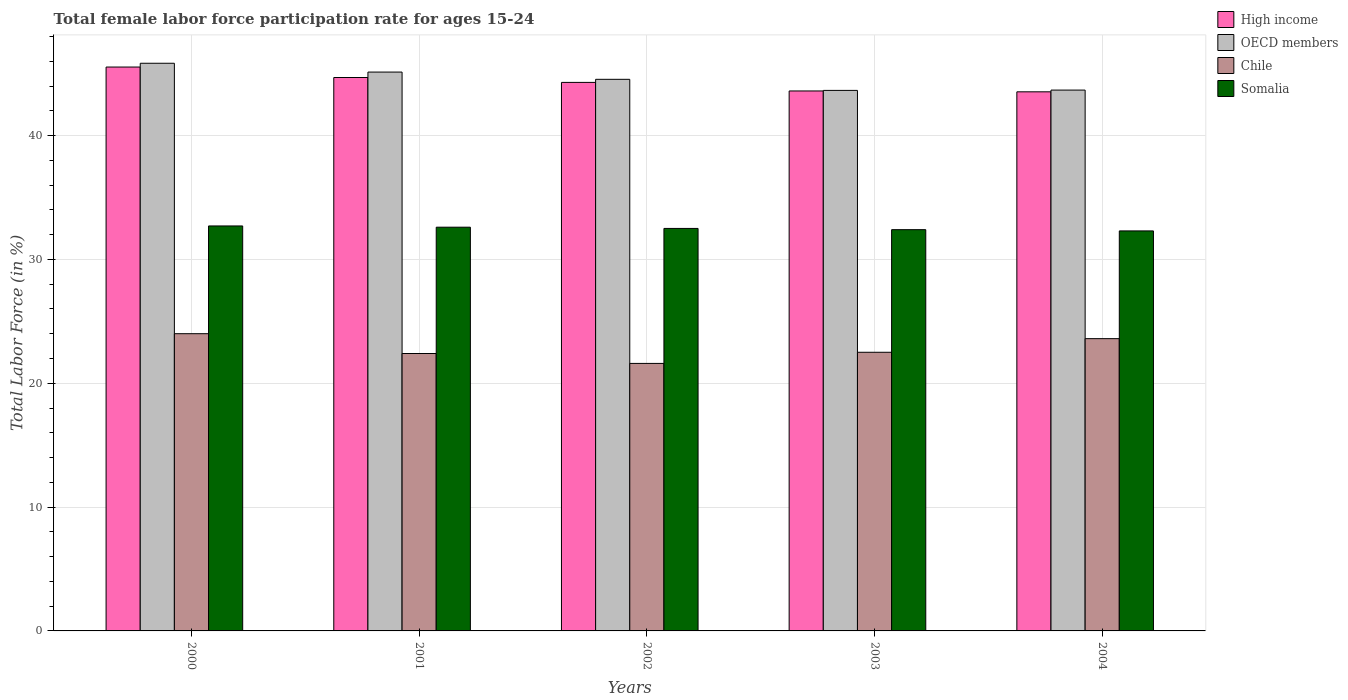How many different coloured bars are there?
Provide a succinct answer. 4. How many groups of bars are there?
Offer a very short reply. 5. Are the number of bars per tick equal to the number of legend labels?
Your answer should be compact. Yes. Are the number of bars on each tick of the X-axis equal?
Your answer should be very brief. Yes. How many bars are there on the 4th tick from the left?
Provide a short and direct response. 4. In how many cases, is the number of bars for a given year not equal to the number of legend labels?
Keep it short and to the point. 0. What is the female labor force participation rate in High income in 2002?
Make the answer very short. 44.29. Across all years, what is the maximum female labor force participation rate in Somalia?
Ensure brevity in your answer.  32.7. Across all years, what is the minimum female labor force participation rate in Chile?
Keep it short and to the point. 21.6. In which year was the female labor force participation rate in High income maximum?
Your answer should be compact. 2000. In which year was the female labor force participation rate in OECD members minimum?
Make the answer very short. 2003. What is the total female labor force participation rate in OECD members in the graph?
Your answer should be very brief. 222.82. What is the difference between the female labor force participation rate in OECD members in 2001 and that in 2002?
Offer a terse response. 0.59. What is the difference between the female labor force participation rate in Somalia in 2003 and the female labor force participation rate in OECD members in 2001?
Provide a short and direct response. -12.73. What is the average female labor force participation rate in Somalia per year?
Make the answer very short. 32.5. In the year 2001, what is the difference between the female labor force participation rate in High income and female labor force participation rate in OECD members?
Offer a very short reply. -0.44. What is the ratio of the female labor force participation rate in Chile in 2002 to that in 2003?
Your response must be concise. 0.96. What is the difference between the highest and the second highest female labor force participation rate in High income?
Give a very brief answer. 0.85. What is the difference between the highest and the lowest female labor force participation rate in High income?
Your answer should be very brief. 2. Is the sum of the female labor force participation rate in Chile in 2002 and 2004 greater than the maximum female labor force participation rate in Somalia across all years?
Give a very brief answer. Yes. What does the 4th bar from the left in 2001 represents?
Your answer should be compact. Somalia. What does the 1st bar from the right in 2004 represents?
Your answer should be compact. Somalia. How many years are there in the graph?
Ensure brevity in your answer.  5. What is the difference between two consecutive major ticks on the Y-axis?
Provide a short and direct response. 10. Are the values on the major ticks of Y-axis written in scientific E-notation?
Ensure brevity in your answer.  No. Does the graph contain grids?
Offer a very short reply. Yes. Where does the legend appear in the graph?
Give a very brief answer. Top right. How are the legend labels stacked?
Your answer should be very brief. Vertical. What is the title of the graph?
Give a very brief answer. Total female labor force participation rate for ages 15-24. Does "Tanzania" appear as one of the legend labels in the graph?
Offer a very short reply. No. What is the Total Labor Force (in %) of High income in 2000?
Your response must be concise. 45.53. What is the Total Labor Force (in %) in OECD members in 2000?
Keep it short and to the point. 45.84. What is the Total Labor Force (in %) of Somalia in 2000?
Offer a terse response. 32.7. What is the Total Labor Force (in %) in High income in 2001?
Provide a succinct answer. 44.69. What is the Total Labor Force (in %) in OECD members in 2001?
Provide a short and direct response. 45.13. What is the Total Labor Force (in %) in Chile in 2001?
Provide a short and direct response. 22.4. What is the Total Labor Force (in %) in Somalia in 2001?
Provide a short and direct response. 32.6. What is the Total Labor Force (in %) in High income in 2002?
Offer a terse response. 44.29. What is the Total Labor Force (in %) of OECD members in 2002?
Offer a terse response. 44.54. What is the Total Labor Force (in %) of Chile in 2002?
Provide a succinct answer. 21.6. What is the Total Labor Force (in %) in Somalia in 2002?
Provide a succinct answer. 32.5. What is the Total Labor Force (in %) in High income in 2003?
Offer a terse response. 43.6. What is the Total Labor Force (in %) of OECD members in 2003?
Provide a short and direct response. 43.65. What is the Total Labor Force (in %) of Somalia in 2003?
Provide a short and direct response. 32.4. What is the Total Labor Force (in %) of High income in 2004?
Provide a succinct answer. 43.53. What is the Total Labor Force (in %) of OECD members in 2004?
Ensure brevity in your answer.  43.67. What is the Total Labor Force (in %) in Chile in 2004?
Give a very brief answer. 23.6. What is the Total Labor Force (in %) of Somalia in 2004?
Provide a short and direct response. 32.3. Across all years, what is the maximum Total Labor Force (in %) in High income?
Give a very brief answer. 45.53. Across all years, what is the maximum Total Labor Force (in %) in OECD members?
Keep it short and to the point. 45.84. Across all years, what is the maximum Total Labor Force (in %) of Chile?
Offer a very short reply. 24. Across all years, what is the maximum Total Labor Force (in %) of Somalia?
Offer a terse response. 32.7. Across all years, what is the minimum Total Labor Force (in %) in High income?
Give a very brief answer. 43.53. Across all years, what is the minimum Total Labor Force (in %) in OECD members?
Offer a terse response. 43.65. Across all years, what is the minimum Total Labor Force (in %) of Chile?
Provide a short and direct response. 21.6. Across all years, what is the minimum Total Labor Force (in %) of Somalia?
Provide a short and direct response. 32.3. What is the total Total Labor Force (in %) of High income in the graph?
Keep it short and to the point. 221.64. What is the total Total Labor Force (in %) of OECD members in the graph?
Give a very brief answer. 222.82. What is the total Total Labor Force (in %) in Chile in the graph?
Offer a terse response. 114.1. What is the total Total Labor Force (in %) of Somalia in the graph?
Your answer should be compact. 162.5. What is the difference between the Total Labor Force (in %) in High income in 2000 and that in 2001?
Provide a short and direct response. 0.85. What is the difference between the Total Labor Force (in %) in OECD members in 2000 and that in 2001?
Offer a very short reply. 0.71. What is the difference between the Total Labor Force (in %) of Chile in 2000 and that in 2001?
Offer a terse response. 1.6. What is the difference between the Total Labor Force (in %) of High income in 2000 and that in 2002?
Your answer should be compact. 1.24. What is the difference between the Total Labor Force (in %) of OECD members in 2000 and that in 2002?
Your answer should be very brief. 1.3. What is the difference between the Total Labor Force (in %) of Chile in 2000 and that in 2002?
Keep it short and to the point. 2.4. What is the difference between the Total Labor Force (in %) of Somalia in 2000 and that in 2002?
Your answer should be very brief. 0.2. What is the difference between the Total Labor Force (in %) of High income in 2000 and that in 2003?
Provide a succinct answer. 1.93. What is the difference between the Total Labor Force (in %) of OECD members in 2000 and that in 2003?
Give a very brief answer. 2.19. What is the difference between the Total Labor Force (in %) in High income in 2000 and that in 2004?
Make the answer very short. 2. What is the difference between the Total Labor Force (in %) of OECD members in 2000 and that in 2004?
Make the answer very short. 2.17. What is the difference between the Total Labor Force (in %) in High income in 2001 and that in 2002?
Offer a very short reply. 0.39. What is the difference between the Total Labor Force (in %) in OECD members in 2001 and that in 2002?
Make the answer very short. 0.59. What is the difference between the Total Labor Force (in %) of High income in 2001 and that in 2003?
Ensure brevity in your answer.  1.09. What is the difference between the Total Labor Force (in %) of OECD members in 2001 and that in 2003?
Offer a terse response. 1.48. What is the difference between the Total Labor Force (in %) in High income in 2001 and that in 2004?
Offer a very short reply. 1.16. What is the difference between the Total Labor Force (in %) of OECD members in 2001 and that in 2004?
Give a very brief answer. 1.45. What is the difference between the Total Labor Force (in %) of High income in 2002 and that in 2003?
Offer a terse response. 0.69. What is the difference between the Total Labor Force (in %) of OECD members in 2002 and that in 2003?
Provide a short and direct response. 0.89. What is the difference between the Total Labor Force (in %) in Chile in 2002 and that in 2003?
Ensure brevity in your answer.  -0.9. What is the difference between the Total Labor Force (in %) of High income in 2002 and that in 2004?
Provide a succinct answer. 0.76. What is the difference between the Total Labor Force (in %) in OECD members in 2002 and that in 2004?
Offer a very short reply. 0.87. What is the difference between the Total Labor Force (in %) of Chile in 2002 and that in 2004?
Provide a short and direct response. -2. What is the difference between the Total Labor Force (in %) in Somalia in 2002 and that in 2004?
Keep it short and to the point. 0.2. What is the difference between the Total Labor Force (in %) in High income in 2003 and that in 2004?
Ensure brevity in your answer.  0.07. What is the difference between the Total Labor Force (in %) in OECD members in 2003 and that in 2004?
Provide a short and direct response. -0.03. What is the difference between the Total Labor Force (in %) in Chile in 2003 and that in 2004?
Give a very brief answer. -1.1. What is the difference between the Total Labor Force (in %) of High income in 2000 and the Total Labor Force (in %) of OECD members in 2001?
Offer a terse response. 0.41. What is the difference between the Total Labor Force (in %) in High income in 2000 and the Total Labor Force (in %) in Chile in 2001?
Keep it short and to the point. 23.13. What is the difference between the Total Labor Force (in %) in High income in 2000 and the Total Labor Force (in %) in Somalia in 2001?
Provide a succinct answer. 12.93. What is the difference between the Total Labor Force (in %) of OECD members in 2000 and the Total Labor Force (in %) of Chile in 2001?
Provide a succinct answer. 23.44. What is the difference between the Total Labor Force (in %) in OECD members in 2000 and the Total Labor Force (in %) in Somalia in 2001?
Offer a very short reply. 13.24. What is the difference between the Total Labor Force (in %) of Chile in 2000 and the Total Labor Force (in %) of Somalia in 2001?
Your answer should be very brief. -8.6. What is the difference between the Total Labor Force (in %) of High income in 2000 and the Total Labor Force (in %) of OECD members in 2002?
Keep it short and to the point. 0.99. What is the difference between the Total Labor Force (in %) of High income in 2000 and the Total Labor Force (in %) of Chile in 2002?
Make the answer very short. 23.93. What is the difference between the Total Labor Force (in %) of High income in 2000 and the Total Labor Force (in %) of Somalia in 2002?
Make the answer very short. 13.03. What is the difference between the Total Labor Force (in %) of OECD members in 2000 and the Total Labor Force (in %) of Chile in 2002?
Your answer should be very brief. 24.24. What is the difference between the Total Labor Force (in %) of OECD members in 2000 and the Total Labor Force (in %) of Somalia in 2002?
Provide a succinct answer. 13.34. What is the difference between the Total Labor Force (in %) of High income in 2000 and the Total Labor Force (in %) of OECD members in 2003?
Make the answer very short. 1.89. What is the difference between the Total Labor Force (in %) in High income in 2000 and the Total Labor Force (in %) in Chile in 2003?
Your answer should be compact. 23.03. What is the difference between the Total Labor Force (in %) in High income in 2000 and the Total Labor Force (in %) in Somalia in 2003?
Ensure brevity in your answer.  13.13. What is the difference between the Total Labor Force (in %) of OECD members in 2000 and the Total Labor Force (in %) of Chile in 2003?
Offer a very short reply. 23.34. What is the difference between the Total Labor Force (in %) in OECD members in 2000 and the Total Labor Force (in %) in Somalia in 2003?
Your answer should be very brief. 13.44. What is the difference between the Total Labor Force (in %) of High income in 2000 and the Total Labor Force (in %) of OECD members in 2004?
Offer a terse response. 1.86. What is the difference between the Total Labor Force (in %) of High income in 2000 and the Total Labor Force (in %) of Chile in 2004?
Ensure brevity in your answer.  21.93. What is the difference between the Total Labor Force (in %) in High income in 2000 and the Total Labor Force (in %) in Somalia in 2004?
Provide a succinct answer. 13.23. What is the difference between the Total Labor Force (in %) in OECD members in 2000 and the Total Labor Force (in %) in Chile in 2004?
Keep it short and to the point. 22.24. What is the difference between the Total Labor Force (in %) in OECD members in 2000 and the Total Labor Force (in %) in Somalia in 2004?
Keep it short and to the point. 13.54. What is the difference between the Total Labor Force (in %) in High income in 2001 and the Total Labor Force (in %) in OECD members in 2002?
Provide a succinct answer. 0.15. What is the difference between the Total Labor Force (in %) of High income in 2001 and the Total Labor Force (in %) of Chile in 2002?
Your answer should be very brief. 23.09. What is the difference between the Total Labor Force (in %) in High income in 2001 and the Total Labor Force (in %) in Somalia in 2002?
Give a very brief answer. 12.19. What is the difference between the Total Labor Force (in %) in OECD members in 2001 and the Total Labor Force (in %) in Chile in 2002?
Your response must be concise. 23.53. What is the difference between the Total Labor Force (in %) of OECD members in 2001 and the Total Labor Force (in %) of Somalia in 2002?
Provide a short and direct response. 12.63. What is the difference between the Total Labor Force (in %) of Chile in 2001 and the Total Labor Force (in %) of Somalia in 2002?
Ensure brevity in your answer.  -10.1. What is the difference between the Total Labor Force (in %) in High income in 2001 and the Total Labor Force (in %) in OECD members in 2003?
Ensure brevity in your answer.  1.04. What is the difference between the Total Labor Force (in %) in High income in 2001 and the Total Labor Force (in %) in Chile in 2003?
Your answer should be compact. 22.19. What is the difference between the Total Labor Force (in %) of High income in 2001 and the Total Labor Force (in %) of Somalia in 2003?
Offer a very short reply. 12.29. What is the difference between the Total Labor Force (in %) in OECD members in 2001 and the Total Labor Force (in %) in Chile in 2003?
Provide a succinct answer. 22.63. What is the difference between the Total Labor Force (in %) of OECD members in 2001 and the Total Labor Force (in %) of Somalia in 2003?
Your answer should be compact. 12.73. What is the difference between the Total Labor Force (in %) in Chile in 2001 and the Total Labor Force (in %) in Somalia in 2003?
Give a very brief answer. -10. What is the difference between the Total Labor Force (in %) in High income in 2001 and the Total Labor Force (in %) in OECD members in 2004?
Ensure brevity in your answer.  1.02. What is the difference between the Total Labor Force (in %) in High income in 2001 and the Total Labor Force (in %) in Chile in 2004?
Provide a succinct answer. 21.09. What is the difference between the Total Labor Force (in %) of High income in 2001 and the Total Labor Force (in %) of Somalia in 2004?
Ensure brevity in your answer.  12.39. What is the difference between the Total Labor Force (in %) in OECD members in 2001 and the Total Labor Force (in %) in Chile in 2004?
Keep it short and to the point. 21.53. What is the difference between the Total Labor Force (in %) of OECD members in 2001 and the Total Labor Force (in %) of Somalia in 2004?
Give a very brief answer. 12.83. What is the difference between the Total Labor Force (in %) in Chile in 2001 and the Total Labor Force (in %) in Somalia in 2004?
Provide a short and direct response. -9.9. What is the difference between the Total Labor Force (in %) in High income in 2002 and the Total Labor Force (in %) in OECD members in 2003?
Ensure brevity in your answer.  0.65. What is the difference between the Total Labor Force (in %) of High income in 2002 and the Total Labor Force (in %) of Chile in 2003?
Ensure brevity in your answer.  21.79. What is the difference between the Total Labor Force (in %) in High income in 2002 and the Total Labor Force (in %) in Somalia in 2003?
Keep it short and to the point. 11.89. What is the difference between the Total Labor Force (in %) of OECD members in 2002 and the Total Labor Force (in %) of Chile in 2003?
Make the answer very short. 22.04. What is the difference between the Total Labor Force (in %) of OECD members in 2002 and the Total Labor Force (in %) of Somalia in 2003?
Offer a very short reply. 12.14. What is the difference between the Total Labor Force (in %) in Chile in 2002 and the Total Labor Force (in %) in Somalia in 2003?
Give a very brief answer. -10.8. What is the difference between the Total Labor Force (in %) of High income in 2002 and the Total Labor Force (in %) of OECD members in 2004?
Provide a short and direct response. 0.62. What is the difference between the Total Labor Force (in %) in High income in 2002 and the Total Labor Force (in %) in Chile in 2004?
Your answer should be very brief. 20.69. What is the difference between the Total Labor Force (in %) of High income in 2002 and the Total Labor Force (in %) of Somalia in 2004?
Keep it short and to the point. 11.99. What is the difference between the Total Labor Force (in %) in OECD members in 2002 and the Total Labor Force (in %) in Chile in 2004?
Offer a very short reply. 20.94. What is the difference between the Total Labor Force (in %) of OECD members in 2002 and the Total Labor Force (in %) of Somalia in 2004?
Your response must be concise. 12.24. What is the difference between the Total Labor Force (in %) of High income in 2003 and the Total Labor Force (in %) of OECD members in 2004?
Offer a very short reply. -0.07. What is the difference between the Total Labor Force (in %) in High income in 2003 and the Total Labor Force (in %) in Chile in 2004?
Offer a very short reply. 20. What is the difference between the Total Labor Force (in %) in High income in 2003 and the Total Labor Force (in %) in Somalia in 2004?
Give a very brief answer. 11.3. What is the difference between the Total Labor Force (in %) in OECD members in 2003 and the Total Labor Force (in %) in Chile in 2004?
Ensure brevity in your answer.  20.05. What is the difference between the Total Labor Force (in %) in OECD members in 2003 and the Total Labor Force (in %) in Somalia in 2004?
Give a very brief answer. 11.35. What is the difference between the Total Labor Force (in %) of Chile in 2003 and the Total Labor Force (in %) of Somalia in 2004?
Provide a short and direct response. -9.8. What is the average Total Labor Force (in %) in High income per year?
Give a very brief answer. 44.33. What is the average Total Labor Force (in %) in OECD members per year?
Ensure brevity in your answer.  44.56. What is the average Total Labor Force (in %) in Chile per year?
Provide a succinct answer. 22.82. What is the average Total Labor Force (in %) in Somalia per year?
Your answer should be very brief. 32.5. In the year 2000, what is the difference between the Total Labor Force (in %) of High income and Total Labor Force (in %) of OECD members?
Give a very brief answer. -0.3. In the year 2000, what is the difference between the Total Labor Force (in %) of High income and Total Labor Force (in %) of Chile?
Your answer should be very brief. 21.53. In the year 2000, what is the difference between the Total Labor Force (in %) in High income and Total Labor Force (in %) in Somalia?
Offer a terse response. 12.83. In the year 2000, what is the difference between the Total Labor Force (in %) in OECD members and Total Labor Force (in %) in Chile?
Your answer should be compact. 21.84. In the year 2000, what is the difference between the Total Labor Force (in %) of OECD members and Total Labor Force (in %) of Somalia?
Ensure brevity in your answer.  13.14. In the year 2001, what is the difference between the Total Labor Force (in %) of High income and Total Labor Force (in %) of OECD members?
Make the answer very short. -0.44. In the year 2001, what is the difference between the Total Labor Force (in %) in High income and Total Labor Force (in %) in Chile?
Provide a succinct answer. 22.29. In the year 2001, what is the difference between the Total Labor Force (in %) in High income and Total Labor Force (in %) in Somalia?
Your answer should be compact. 12.09. In the year 2001, what is the difference between the Total Labor Force (in %) of OECD members and Total Labor Force (in %) of Chile?
Your answer should be compact. 22.73. In the year 2001, what is the difference between the Total Labor Force (in %) of OECD members and Total Labor Force (in %) of Somalia?
Your response must be concise. 12.53. In the year 2001, what is the difference between the Total Labor Force (in %) in Chile and Total Labor Force (in %) in Somalia?
Provide a short and direct response. -10.2. In the year 2002, what is the difference between the Total Labor Force (in %) of High income and Total Labor Force (in %) of OECD members?
Your answer should be very brief. -0.25. In the year 2002, what is the difference between the Total Labor Force (in %) in High income and Total Labor Force (in %) in Chile?
Offer a very short reply. 22.69. In the year 2002, what is the difference between the Total Labor Force (in %) of High income and Total Labor Force (in %) of Somalia?
Your response must be concise. 11.79. In the year 2002, what is the difference between the Total Labor Force (in %) of OECD members and Total Labor Force (in %) of Chile?
Give a very brief answer. 22.94. In the year 2002, what is the difference between the Total Labor Force (in %) of OECD members and Total Labor Force (in %) of Somalia?
Your answer should be compact. 12.04. In the year 2002, what is the difference between the Total Labor Force (in %) of Chile and Total Labor Force (in %) of Somalia?
Make the answer very short. -10.9. In the year 2003, what is the difference between the Total Labor Force (in %) in High income and Total Labor Force (in %) in OECD members?
Offer a very short reply. -0.05. In the year 2003, what is the difference between the Total Labor Force (in %) in High income and Total Labor Force (in %) in Chile?
Provide a short and direct response. 21.1. In the year 2003, what is the difference between the Total Labor Force (in %) of High income and Total Labor Force (in %) of Somalia?
Your answer should be very brief. 11.2. In the year 2003, what is the difference between the Total Labor Force (in %) in OECD members and Total Labor Force (in %) in Chile?
Offer a very short reply. 21.15. In the year 2003, what is the difference between the Total Labor Force (in %) of OECD members and Total Labor Force (in %) of Somalia?
Make the answer very short. 11.25. In the year 2003, what is the difference between the Total Labor Force (in %) of Chile and Total Labor Force (in %) of Somalia?
Offer a very short reply. -9.9. In the year 2004, what is the difference between the Total Labor Force (in %) of High income and Total Labor Force (in %) of OECD members?
Offer a very short reply. -0.14. In the year 2004, what is the difference between the Total Labor Force (in %) in High income and Total Labor Force (in %) in Chile?
Keep it short and to the point. 19.93. In the year 2004, what is the difference between the Total Labor Force (in %) of High income and Total Labor Force (in %) of Somalia?
Provide a short and direct response. 11.23. In the year 2004, what is the difference between the Total Labor Force (in %) of OECD members and Total Labor Force (in %) of Chile?
Keep it short and to the point. 20.07. In the year 2004, what is the difference between the Total Labor Force (in %) in OECD members and Total Labor Force (in %) in Somalia?
Your answer should be compact. 11.37. What is the ratio of the Total Labor Force (in %) of High income in 2000 to that in 2001?
Your answer should be very brief. 1.02. What is the ratio of the Total Labor Force (in %) in OECD members in 2000 to that in 2001?
Offer a terse response. 1.02. What is the ratio of the Total Labor Force (in %) in Chile in 2000 to that in 2001?
Ensure brevity in your answer.  1.07. What is the ratio of the Total Labor Force (in %) in High income in 2000 to that in 2002?
Offer a very short reply. 1.03. What is the ratio of the Total Labor Force (in %) in OECD members in 2000 to that in 2002?
Your answer should be very brief. 1.03. What is the ratio of the Total Labor Force (in %) of Chile in 2000 to that in 2002?
Your response must be concise. 1.11. What is the ratio of the Total Labor Force (in %) of Somalia in 2000 to that in 2002?
Offer a very short reply. 1.01. What is the ratio of the Total Labor Force (in %) of High income in 2000 to that in 2003?
Provide a succinct answer. 1.04. What is the ratio of the Total Labor Force (in %) of OECD members in 2000 to that in 2003?
Provide a succinct answer. 1.05. What is the ratio of the Total Labor Force (in %) in Chile in 2000 to that in 2003?
Provide a short and direct response. 1.07. What is the ratio of the Total Labor Force (in %) of Somalia in 2000 to that in 2003?
Keep it short and to the point. 1.01. What is the ratio of the Total Labor Force (in %) of High income in 2000 to that in 2004?
Offer a very short reply. 1.05. What is the ratio of the Total Labor Force (in %) in OECD members in 2000 to that in 2004?
Your answer should be very brief. 1.05. What is the ratio of the Total Labor Force (in %) in Chile in 2000 to that in 2004?
Offer a terse response. 1.02. What is the ratio of the Total Labor Force (in %) in Somalia in 2000 to that in 2004?
Give a very brief answer. 1.01. What is the ratio of the Total Labor Force (in %) of High income in 2001 to that in 2002?
Offer a terse response. 1.01. What is the ratio of the Total Labor Force (in %) of OECD members in 2001 to that in 2002?
Offer a very short reply. 1.01. What is the ratio of the Total Labor Force (in %) in High income in 2001 to that in 2003?
Provide a succinct answer. 1.02. What is the ratio of the Total Labor Force (in %) in OECD members in 2001 to that in 2003?
Your answer should be very brief. 1.03. What is the ratio of the Total Labor Force (in %) in Chile in 2001 to that in 2003?
Offer a terse response. 1. What is the ratio of the Total Labor Force (in %) in Somalia in 2001 to that in 2003?
Keep it short and to the point. 1.01. What is the ratio of the Total Labor Force (in %) of High income in 2001 to that in 2004?
Your answer should be very brief. 1.03. What is the ratio of the Total Labor Force (in %) in Chile in 2001 to that in 2004?
Your response must be concise. 0.95. What is the ratio of the Total Labor Force (in %) of Somalia in 2001 to that in 2004?
Offer a very short reply. 1.01. What is the ratio of the Total Labor Force (in %) in High income in 2002 to that in 2003?
Provide a short and direct response. 1.02. What is the ratio of the Total Labor Force (in %) of OECD members in 2002 to that in 2003?
Offer a very short reply. 1.02. What is the ratio of the Total Labor Force (in %) in Chile in 2002 to that in 2003?
Provide a short and direct response. 0.96. What is the ratio of the Total Labor Force (in %) of Somalia in 2002 to that in 2003?
Provide a short and direct response. 1. What is the ratio of the Total Labor Force (in %) in High income in 2002 to that in 2004?
Your answer should be compact. 1.02. What is the ratio of the Total Labor Force (in %) of OECD members in 2002 to that in 2004?
Make the answer very short. 1.02. What is the ratio of the Total Labor Force (in %) of Chile in 2002 to that in 2004?
Provide a short and direct response. 0.92. What is the ratio of the Total Labor Force (in %) of OECD members in 2003 to that in 2004?
Offer a very short reply. 1. What is the ratio of the Total Labor Force (in %) in Chile in 2003 to that in 2004?
Offer a very short reply. 0.95. What is the ratio of the Total Labor Force (in %) of Somalia in 2003 to that in 2004?
Ensure brevity in your answer.  1. What is the difference between the highest and the second highest Total Labor Force (in %) of High income?
Your response must be concise. 0.85. What is the difference between the highest and the second highest Total Labor Force (in %) of OECD members?
Offer a very short reply. 0.71. What is the difference between the highest and the second highest Total Labor Force (in %) of Somalia?
Keep it short and to the point. 0.1. What is the difference between the highest and the lowest Total Labor Force (in %) of High income?
Provide a short and direct response. 2. What is the difference between the highest and the lowest Total Labor Force (in %) in OECD members?
Keep it short and to the point. 2.19. 